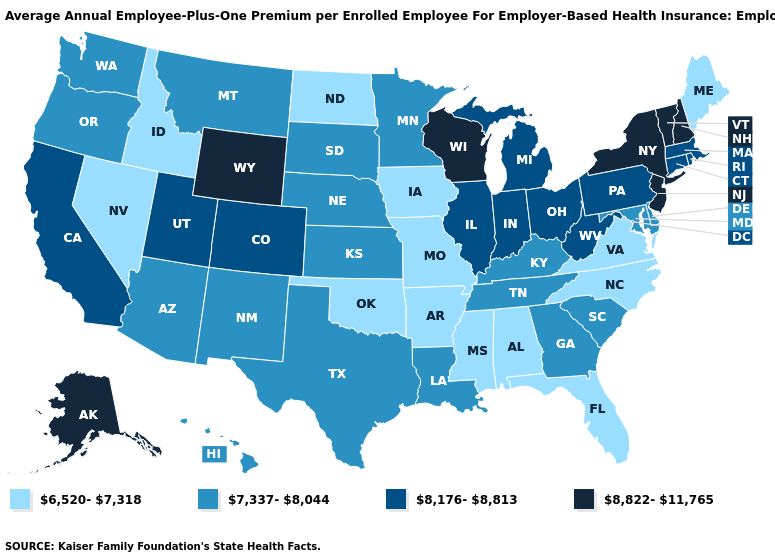Name the states that have a value in the range 6,520-7,318?
Concise answer only. Alabama, Arkansas, Florida, Idaho, Iowa, Maine, Mississippi, Missouri, Nevada, North Carolina, North Dakota, Oklahoma, Virginia. Name the states that have a value in the range 7,337-8,044?
Write a very short answer. Arizona, Delaware, Georgia, Hawaii, Kansas, Kentucky, Louisiana, Maryland, Minnesota, Montana, Nebraska, New Mexico, Oregon, South Carolina, South Dakota, Tennessee, Texas, Washington. Name the states that have a value in the range 7,337-8,044?
Write a very short answer. Arizona, Delaware, Georgia, Hawaii, Kansas, Kentucky, Louisiana, Maryland, Minnesota, Montana, Nebraska, New Mexico, Oregon, South Carolina, South Dakota, Tennessee, Texas, Washington. Is the legend a continuous bar?
Be succinct. No. How many symbols are there in the legend?
Be succinct. 4. Name the states that have a value in the range 8,822-11,765?
Short answer required. Alaska, New Hampshire, New Jersey, New York, Vermont, Wisconsin, Wyoming. What is the value of Vermont?
Quick response, please. 8,822-11,765. What is the lowest value in states that border Wisconsin?
Give a very brief answer. 6,520-7,318. Name the states that have a value in the range 6,520-7,318?
Concise answer only. Alabama, Arkansas, Florida, Idaho, Iowa, Maine, Mississippi, Missouri, Nevada, North Carolina, North Dakota, Oklahoma, Virginia. What is the value of Arkansas?
Give a very brief answer. 6,520-7,318. What is the value of Illinois?
Keep it brief. 8,176-8,813. What is the highest value in the South ?
Concise answer only. 8,176-8,813. Among the states that border Washington , which have the highest value?
Concise answer only. Oregon. Which states have the lowest value in the MidWest?
Keep it brief. Iowa, Missouri, North Dakota. What is the lowest value in the USA?
Short answer required. 6,520-7,318. 